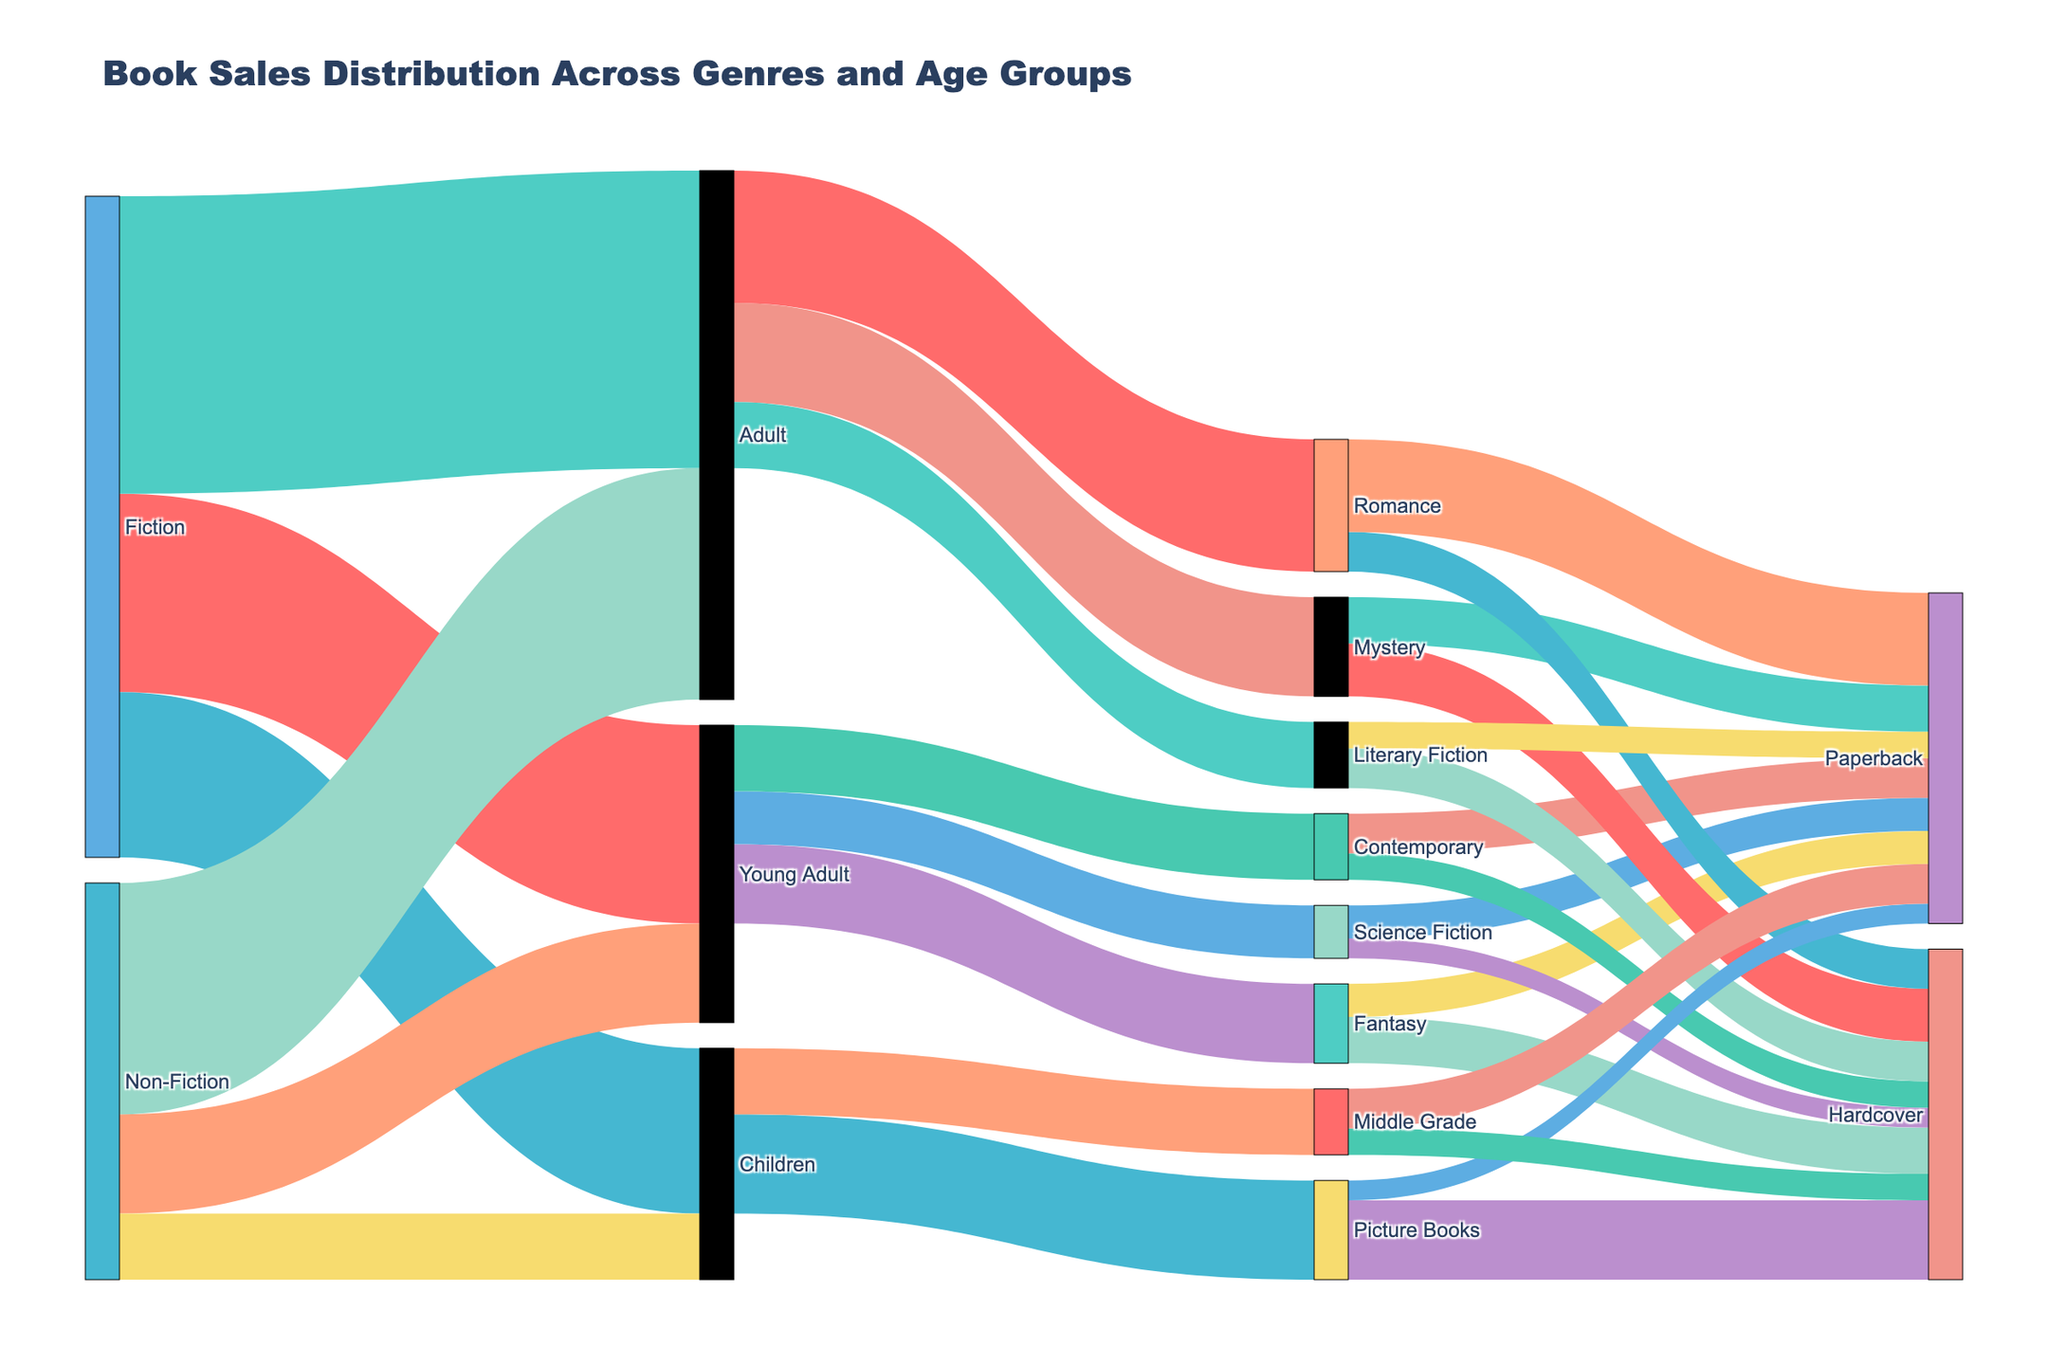What's the title of the Sankey Diagram? The title of the plot is usually located at the top of the figure. You can see the text displayed prominently.
Answer: Book Sales Distribution Across Genres and Age Groups How many different labels are used in the Sankey Diagram? By counting the unique labels displayed on the Sankey Diagram, you can determine how many different labels are used.
Answer: 16 Which genre has the highest sales to Adult? By following the connections from each genre to the Adult category and comparing the values, you can see that Fiction contributes the highest sales to Adult.
Answer: Fiction What is the total book sales value for the Young Adult age group? To find the total, we need to sum all the values that link to the Young Adult category. The values are: Fiction to Young Adult (30,000) and Non-Fiction to Young Adult (15,000).
Answer: 45,000 How do the sales of Picture Books in Children compare to other subgenres in Children? By examining the nodes connected to Children and observing the value for each, you can compare: Picture Books (15,000), Middle Grade (10,000). Picture Books has higher sales compared to Middle Grade.
Answer: Higher Which age group does the Science Fiction subgenre connect to, and what is the sum of its book sales? By tracing the connections, you can see that Science Fiction links to Young Adult. Summing the values from Science Fiction to Hardcover (3,000) and Paperback (5,000) gives us a total.
Answer: 8,000 What is the total sales value of Hardcover books? To find this value, sum the values of all links that target Hardcover across various subgenres. Values are: Fantasy (7,000), Science Fiction (3,000), Contemporary (4,000), Mystery (8,000), Romance (6,000), Literary Fiction (6,000), Picture Books (12,000), and Middle Grade (4,000).
Answer: 50,000 What is the most popular book format in the Romance subgenre? By comparing the sales values within the Romance subgenre, you can observe that Paperback (14,000) has higher sales than Hardcover (6,000).
Answer: Paperback How do the sales of Fiction for Children compare to Non-Fiction for Children? By comparing the values of the connections: Fiction to Children (25,000) and Non-Fiction to Children (10,000), Fiction has higher sales.
Answer: 15,000 more Which age group does Contemporary subgenre predominantly connect to, and what's the predominant sales format? By tracing the connections, you can see Contemporary links to Young Adult. Observing the format connections: Hardcover (4,000) and Paperback (6,000), Paperback has higher sales.
Answer: Young Adult, Paperback 